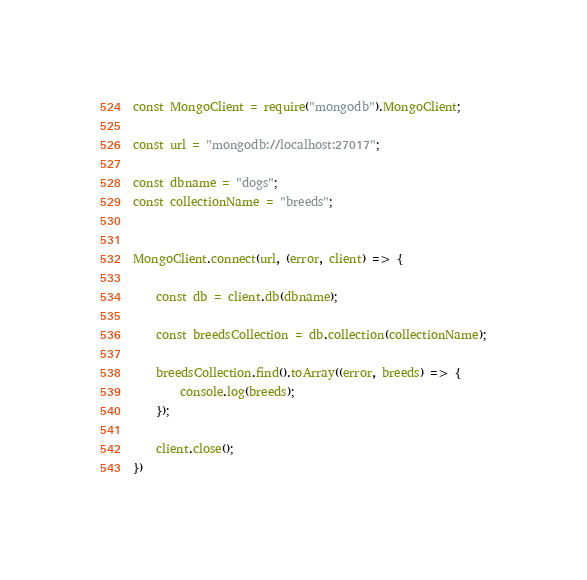Convert code to text. <code><loc_0><loc_0><loc_500><loc_500><_JavaScript_>const MongoClient = require("mongodb").MongoClient;

const url = "mongodb://localhost:27017";

const dbname = "dogs";
const collectionName = "breeds";


MongoClient.connect(url, (error, client) => {

    const db = client.db(dbname);

    const breedsCollection = db.collection(collectionName);

    breedsCollection.find().toArray((error, breeds) => {
        console.log(breeds);
    });

    client.close();
})</code> 